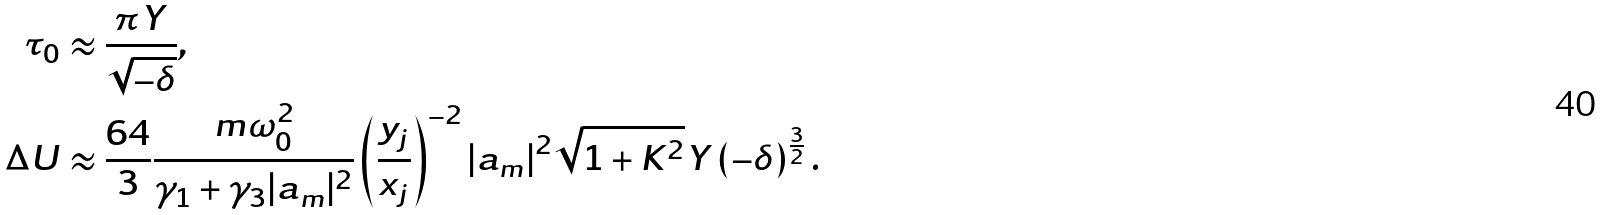<formula> <loc_0><loc_0><loc_500><loc_500>\tau _ { 0 } & \approx \frac { \pi Y } { \sqrt { - \delta } } , \\ \Delta U & \approx \frac { 6 4 } { 3 } \frac { m \omega _ { 0 } ^ { 2 } } { \gamma _ { 1 } + \gamma _ { 3 } | a _ { m } | ^ { 2 } } \left ( \frac { y _ { j } } { x _ { j } } \right ) ^ { - 2 } | a _ { m } | ^ { 2 } \sqrt { 1 + K ^ { 2 } } Y \left ( - \delta \right ) ^ { \frac { 3 } { 2 } } .</formula> 